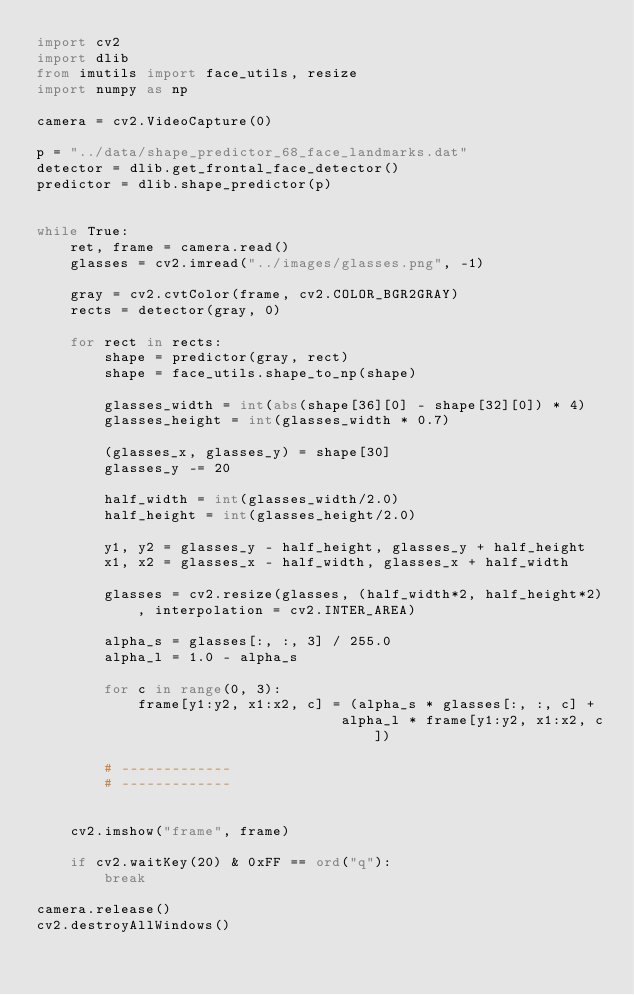Convert code to text. <code><loc_0><loc_0><loc_500><loc_500><_Python_>import cv2
import dlib
from imutils import face_utils, resize
import numpy as np

camera = cv2.VideoCapture(0)

p = "../data/shape_predictor_68_face_landmarks.dat"
detector = dlib.get_frontal_face_detector()
predictor = dlib.shape_predictor(p)


while True:
    ret, frame = camera.read()
    glasses = cv2.imread("../images/glasses.png", -1)
    
    gray = cv2.cvtColor(frame, cv2.COLOR_BGR2GRAY)
    rects = detector(gray, 0)

    for rect in rects:
        shape = predictor(gray, rect)
        shape = face_utils.shape_to_np(shape)

        glasses_width = int(abs(shape[36][0] - shape[32][0]) * 4)
        glasses_height = int(glasses_width * 0.7)

        (glasses_x, glasses_y) = shape[30]
        glasses_y -= 20

        half_width = int(glasses_width/2.0)
        half_height = int(glasses_height/2.0)

        y1, y2 = glasses_y - half_height, glasses_y + half_height
        x1, x2 = glasses_x - half_width, glasses_x + half_width

        glasses = cv2.resize(glasses, (half_width*2, half_height*2), interpolation = cv2.INTER_AREA)

        alpha_s = glasses[:, :, 3] / 255.0
        alpha_l = 1.0 - alpha_s

        for c in range(0, 3):
            frame[y1:y2, x1:x2, c] = (alpha_s * glasses[:, :, c] + 
                                    alpha_l * frame[y1:y2, x1:x2, c])

        # -------------
        # -------------


    cv2.imshow("frame", frame)

    if cv2.waitKey(20) & 0xFF == ord("q"):
        break

camera.release()
cv2.destroyAllWindows()
</code> 